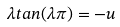Convert formula to latex. <formula><loc_0><loc_0><loc_500><loc_500>\lambda t a n ( \lambda \pi ) = - u</formula> 